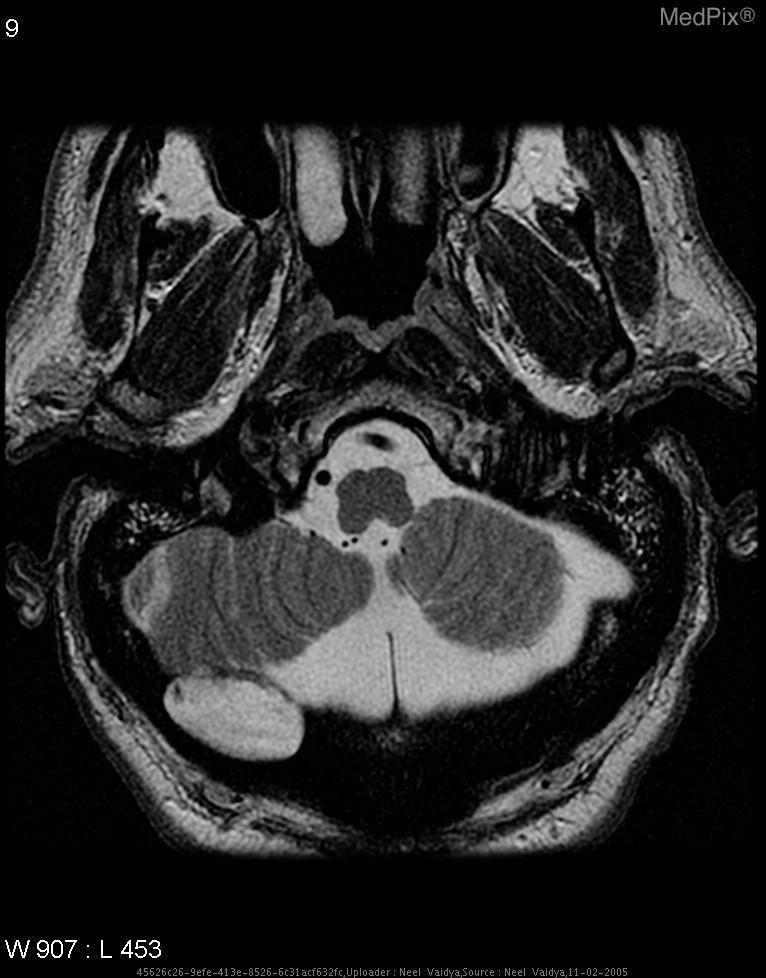Is the lesion causing significant brainstem herniation?
Concise answer only. No. Is there herniation of the brainstem secondary to the lesion
Quick response, please. No. Does the mass have a smooth appearing border?
Answer briefly. Yes. Is the mass well-defined?
Answer briefly. Yes. Is the cerebellum in view?
Quick response, please. Yes. Is the vertebro-basilar arterial network viewed in this section?
Answer briefly. Yes. Is the vertebral artery/basilar artery located in this image?
Concise answer only. Yes. 